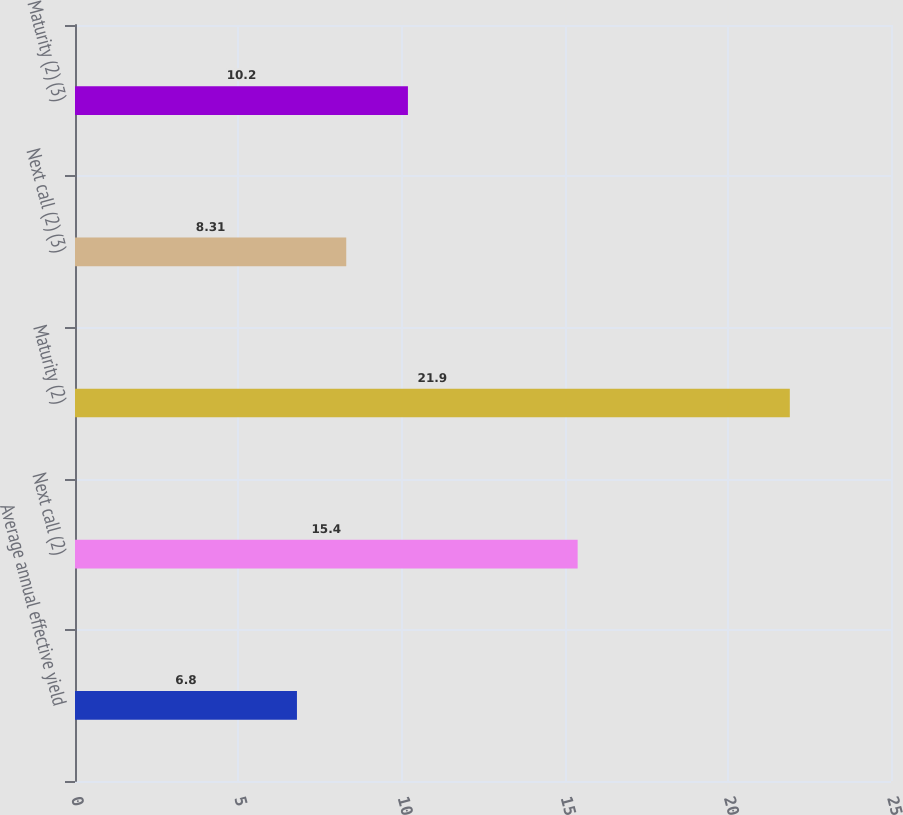Convert chart to OTSL. <chart><loc_0><loc_0><loc_500><loc_500><bar_chart><fcel>Average annual effective yield<fcel>Next call (2)<fcel>Maturity (2)<fcel>Next call (2) (3)<fcel>Maturity (2) (3)<nl><fcel>6.8<fcel>15.4<fcel>21.9<fcel>8.31<fcel>10.2<nl></chart> 